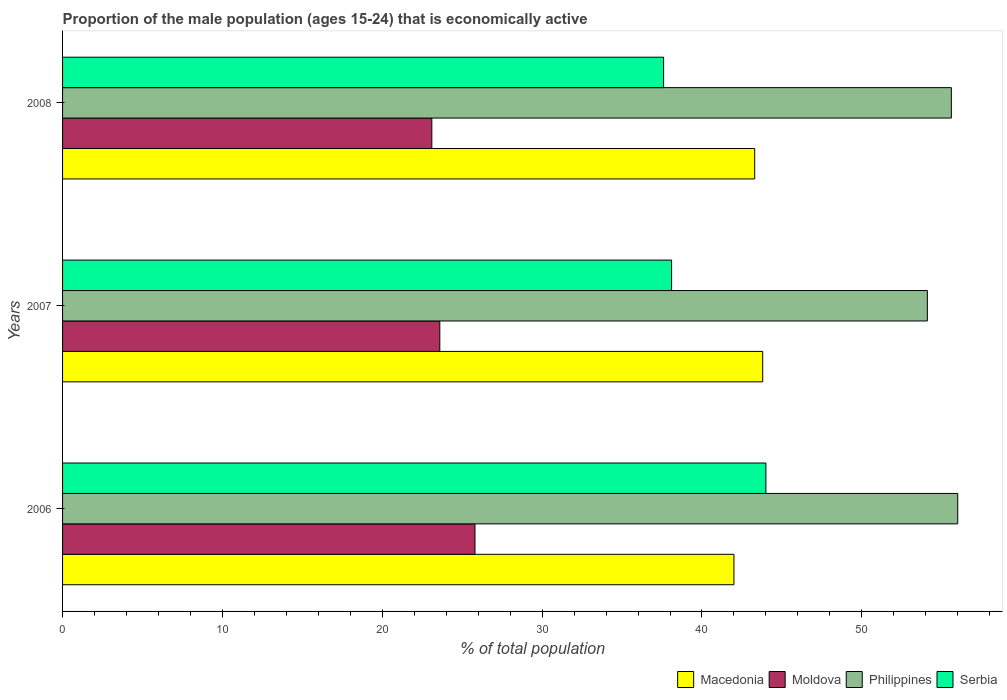How many groups of bars are there?
Offer a very short reply. 3. How many bars are there on the 2nd tick from the top?
Ensure brevity in your answer.  4. What is the label of the 2nd group of bars from the top?
Your answer should be compact. 2007. In how many cases, is the number of bars for a given year not equal to the number of legend labels?
Offer a terse response. 0. What is the proportion of the male population that is economically active in Macedonia in 2007?
Your answer should be compact. 43.8. Across all years, what is the maximum proportion of the male population that is economically active in Macedonia?
Your response must be concise. 43.8. Across all years, what is the minimum proportion of the male population that is economically active in Moldova?
Offer a terse response. 23.1. In which year was the proportion of the male population that is economically active in Serbia maximum?
Offer a very short reply. 2006. In which year was the proportion of the male population that is economically active in Serbia minimum?
Make the answer very short. 2008. What is the total proportion of the male population that is economically active in Serbia in the graph?
Make the answer very short. 119.7. What is the difference between the proportion of the male population that is economically active in Moldova in 2006 and that in 2008?
Offer a very short reply. 2.7. What is the difference between the proportion of the male population that is economically active in Philippines in 2008 and the proportion of the male population that is economically active in Moldova in 2007?
Offer a very short reply. 32. What is the average proportion of the male population that is economically active in Moldova per year?
Your answer should be very brief. 24.17. What is the ratio of the proportion of the male population that is economically active in Serbia in 2007 to that in 2008?
Give a very brief answer. 1.01. Is the proportion of the male population that is economically active in Moldova in 2006 less than that in 2008?
Give a very brief answer. No. Is the difference between the proportion of the male population that is economically active in Philippines in 2006 and 2007 greater than the difference between the proportion of the male population that is economically active in Macedonia in 2006 and 2007?
Ensure brevity in your answer.  Yes. What is the difference between the highest and the second highest proportion of the male population that is economically active in Moldova?
Ensure brevity in your answer.  2.2. What is the difference between the highest and the lowest proportion of the male population that is economically active in Serbia?
Ensure brevity in your answer.  6.4. In how many years, is the proportion of the male population that is economically active in Macedonia greater than the average proportion of the male population that is economically active in Macedonia taken over all years?
Provide a succinct answer. 2. Is the sum of the proportion of the male population that is economically active in Serbia in 2006 and 2007 greater than the maximum proportion of the male population that is economically active in Moldova across all years?
Offer a very short reply. Yes. Is it the case that in every year, the sum of the proportion of the male population that is economically active in Moldova and proportion of the male population that is economically active in Philippines is greater than the sum of proportion of the male population that is economically active in Macedonia and proportion of the male population that is economically active in Serbia?
Offer a very short reply. No. What does the 4th bar from the top in 2007 represents?
Offer a very short reply. Macedonia. What does the 4th bar from the bottom in 2008 represents?
Your answer should be very brief. Serbia. Is it the case that in every year, the sum of the proportion of the male population that is economically active in Philippines and proportion of the male population that is economically active in Macedonia is greater than the proportion of the male population that is economically active in Moldova?
Provide a short and direct response. Yes. How many bars are there?
Provide a succinct answer. 12. Are all the bars in the graph horizontal?
Provide a succinct answer. Yes. How many years are there in the graph?
Provide a succinct answer. 3. What is the difference between two consecutive major ticks on the X-axis?
Ensure brevity in your answer.  10. Are the values on the major ticks of X-axis written in scientific E-notation?
Ensure brevity in your answer.  No. Where does the legend appear in the graph?
Give a very brief answer. Bottom right. What is the title of the graph?
Offer a terse response. Proportion of the male population (ages 15-24) that is economically active. Does "OECD members" appear as one of the legend labels in the graph?
Offer a terse response. No. What is the label or title of the X-axis?
Your response must be concise. % of total population. What is the % of total population in Macedonia in 2006?
Provide a succinct answer. 42. What is the % of total population of Moldova in 2006?
Your response must be concise. 25.8. What is the % of total population of Philippines in 2006?
Offer a terse response. 56. What is the % of total population of Macedonia in 2007?
Provide a succinct answer. 43.8. What is the % of total population of Moldova in 2007?
Ensure brevity in your answer.  23.6. What is the % of total population of Philippines in 2007?
Provide a succinct answer. 54.1. What is the % of total population of Serbia in 2007?
Your answer should be compact. 38.1. What is the % of total population in Macedonia in 2008?
Give a very brief answer. 43.3. What is the % of total population of Moldova in 2008?
Provide a short and direct response. 23.1. What is the % of total population of Philippines in 2008?
Provide a succinct answer. 55.6. What is the % of total population of Serbia in 2008?
Give a very brief answer. 37.6. Across all years, what is the maximum % of total population in Macedonia?
Make the answer very short. 43.8. Across all years, what is the maximum % of total population of Moldova?
Offer a very short reply. 25.8. Across all years, what is the maximum % of total population of Philippines?
Make the answer very short. 56. Across all years, what is the maximum % of total population of Serbia?
Your response must be concise. 44. Across all years, what is the minimum % of total population in Macedonia?
Ensure brevity in your answer.  42. Across all years, what is the minimum % of total population in Moldova?
Give a very brief answer. 23.1. Across all years, what is the minimum % of total population of Philippines?
Provide a succinct answer. 54.1. Across all years, what is the minimum % of total population in Serbia?
Your answer should be very brief. 37.6. What is the total % of total population of Macedonia in the graph?
Your response must be concise. 129.1. What is the total % of total population in Moldova in the graph?
Offer a very short reply. 72.5. What is the total % of total population in Philippines in the graph?
Your response must be concise. 165.7. What is the total % of total population of Serbia in the graph?
Ensure brevity in your answer.  119.7. What is the difference between the % of total population in Philippines in 2006 and that in 2007?
Offer a terse response. 1.9. What is the difference between the % of total population in Macedonia in 2006 and that in 2008?
Ensure brevity in your answer.  -1.3. What is the difference between the % of total population in Serbia in 2006 and that in 2008?
Provide a succinct answer. 6.4. What is the difference between the % of total population of Macedonia in 2007 and that in 2008?
Offer a very short reply. 0.5. What is the difference between the % of total population in Moldova in 2007 and that in 2008?
Ensure brevity in your answer.  0.5. What is the difference between the % of total population of Serbia in 2007 and that in 2008?
Provide a short and direct response. 0.5. What is the difference between the % of total population in Macedonia in 2006 and the % of total population in Moldova in 2007?
Keep it short and to the point. 18.4. What is the difference between the % of total population of Moldova in 2006 and the % of total population of Philippines in 2007?
Provide a short and direct response. -28.3. What is the difference between the % of total population in Macedonia in 2006 and the % of total population in Moldova in 2008?
Offer a very short reply. 18.9. What is the difference between the % of total population of Macedonia in 2006 and the % of total population of Serbia in 2008?
Your response must be concise. 4.4. What is the difference between the % of total population in Moldova in 2006 and the % of total population in Philippines in 2008?
Make the answer very short. -29.8. What is the difference between the % of total population in Moldova in 2006 and the % of total population in Serbia in 2008?
Give a very brief answer. -11.8. What is the difference between the % of total population of Macedonia in 2007 and the % of total population of Moldova in 2008?
Provide a short and direct response. 20.7. What is the difference between the % of total population of Moldova in 2007 and the % of total population of Philippines in 2008?
Provide a short and direct response. -32. What is the difference between the % of total population of Moldova in 2007 and the % of total population of Serbia in 2008?
Provide a succinct answer. -14. What is the difference between the % of total population of Philippines in 2007 and the % of total population of Serbia in 2008?
Provide a succinct answer. 16.5. What is the average % of total population of Macedonia per year?
Provide a succinct answer. 43.03. What is the average % of total population of Moldova per year?
Offer a terse response. 24.17. What is the average % of total population of Philippines per year?
Make the answer very short. 55.23. What is the average % of total population of Serbia per year?
Your answer should be compact. 39.9. In the year 2006, what is the difference between the % of total population of Macedonia and % of total population of Philippines?
Your answer should be very brief. -14. In the year 2006, what is the difference between the % of total population of Moldova and % of total population of Philippines?
Make the answer very short. -30.2. In the year 2006, what is the difference between the % of total population in Moldova and % of total population in Serbia?
Provide a short and direct response. -18.2. In the year 2006, what is the difference between the % of total population in Philippines and % of total population in Serbia?
Your response must be concise. 12. In the year 2007, what is the difference between the % of total population of Macedonia and % of total population of Moldova?
Provide a short and direct response. 20.2. In the year 2007, what is the difference between the % of total population of Macedonia and % of total population of Philippines?
Make the answer very short. -10.3. In the year 2007, what is the difference between the % of total population in Moldova and % of total population in Philippines?
Make the answer very short. -30.5. In the year 2008, what is the difference between the % of total population in Macedonia and % of total population in Moldova?
Make the answer very short. 20.2. In the year 2008, what is the difference between the % of total population in Moldova and % of total population in Philippines?
Your answer should be very brief. -32.5. What is the ratio of the % of total population in Macedonia in 2006 to that in 2007?
Give a very brief answer. 0.96. What is the ratio of the % of total population of Moldova in 2006 to that in 2007?
Make the answer very short. 1.09. What is the ratio of the % of total population in Philippines in 2006 to that in 2007?
Give a very brief answer. 1.04. What is the ratio of the % of total population of Serbia in 2006 to that in 2007?
Give a very brief answer. 1.15. What is the ratio of the % of total population of Macedonia in 2006 to that in 2008?
Your answer should be compact. 0.97. What is the ratio of the % of total population of Moldova in 2006 to that in 2008?
Your answer should be very brief. 1.12. What is the ratio of the % of total population in Philippines in 2006 to that in 2008?
Provide a succinct answer. 1.01. What is the ratio of the % of total population in Serbia in 2006 to that in 2008?
Give a very brief answer. 1.17. What is the ratio of the % of total population in Macedonia in 2007 to that in 2008?
Make the answer very short. 1.01. What is the ratio of the % of total population in Moldova in 2007 to that in 2008?
Your answer should be compact. 1.02. What is the ratio of the % of total population in Serbia in 2007 to that in 2008?
Your answer should be very brief. 1.01. What is the difference between the highest and the second highest % of total population of Macedonia?
Make the answer very short. 0.5. What is the difference between the highest and the lowest % of total population in Philippines?
Make the answer very short. 1.9. What is the difference between the highest and the lowest % of total population in Serbia?
Your response must be concise. 6.4. 